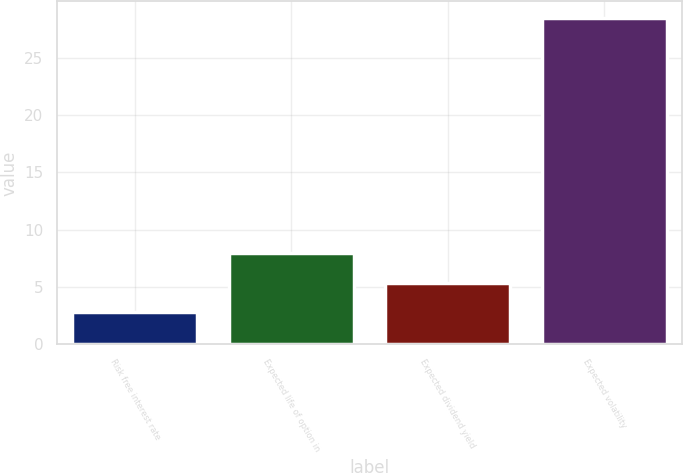<chart> <loc_0><loc_0><loc_500><loc_500><bar_chart><fcel>Risk free interest rate<fcel>Expected life of option in<fcel>Expected dividend yield<fcel>Expected volatility<nl><fcel>2.8<fcel>7.94<fcel>5.37<fcel>28.5<nl></chart> 